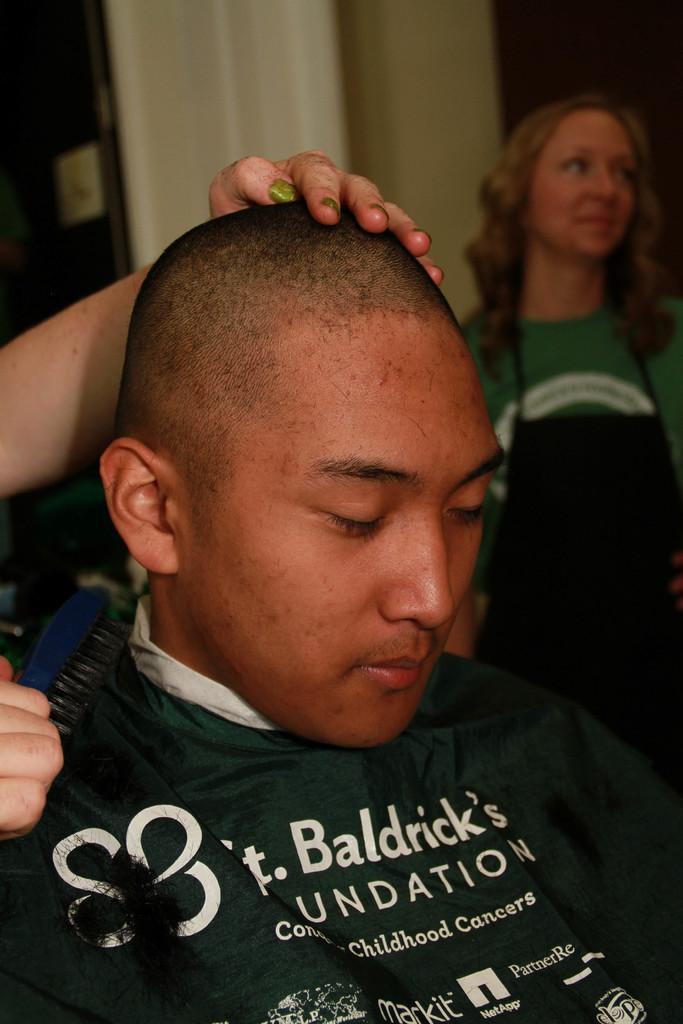Could you give a brief overview of what you see in this image? In this picture I can see there is a man sitting in the chair and there is a person holding his head and a hairbrush. There is another woman in the backdrop and the backdrop is blurred. 